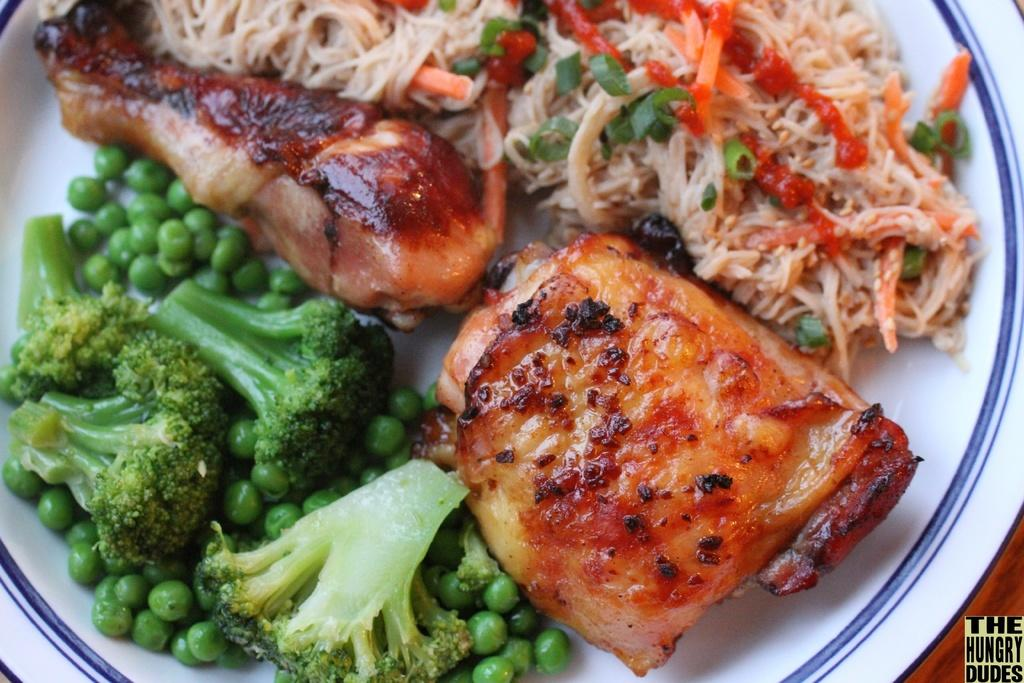What is on the plate that is visible in the image? There is a plate with food in the image. What specific vegetables are included in the food? The food contains broccoli and green peas. What type of meat is included in the food? The food contains a chicken leg piece. What type of carbohydrate is included in the food? The food contains noodles. What type of pear is sitting on the cactus in the image? There is no pear or cactus present in the image; it features a plate with food containing broccoli, green peas, a chicken leg piece, and noodles. 